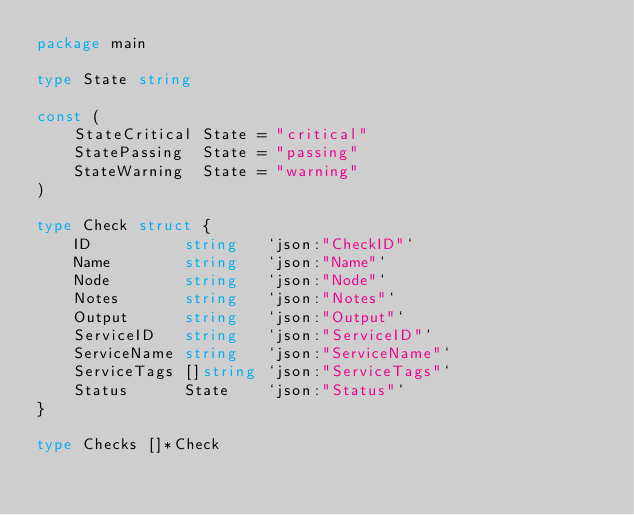Convert code to text. <code><loc_0><loc_0><loc_500><loc_500><_Go_>package main

type State string

const (
	StateCritical State = "critical"
	StatePassing  State = "passing"
	StateWarning  State = "warning"
)

type Check struct {
	ID          string   `json:"CheckID"`
	Name        string   `json:"Name"`
	Node        string   `json:"Node"`
	Notes       string   `json:"Notes"`
	Output      string   `json:"Output"`
	ServiceID   string   `json:"ServiceID"`
	ServiceName string   `json:"ServiceName"`
	ServiceTags []string `json:"ServiceTags"`
	Status      State    `json:"Status"`
}

type Checks []*Check
</code> 